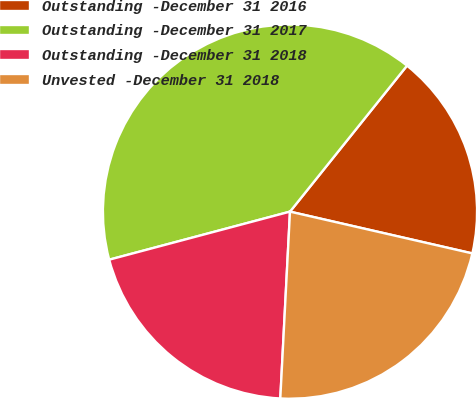<chart> <loc_0><loc_0><loc_500><loc_500><pie_chart><fcel>Outstanding -December 31 2016<fcel>Outstanding -December 31 2017<fcel>Outstanding -December 31 2018<fcel>Unvested -December 31 2018<nl><fcel>17.83%<fcel>39.89%<fcel>20.04%<fcel>22.24%<nl></chart> 